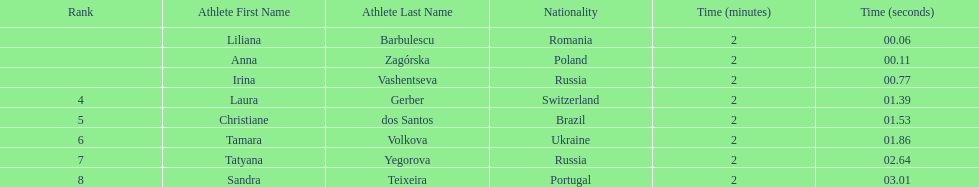Which country had the most finishers in the top 8? Russia. 